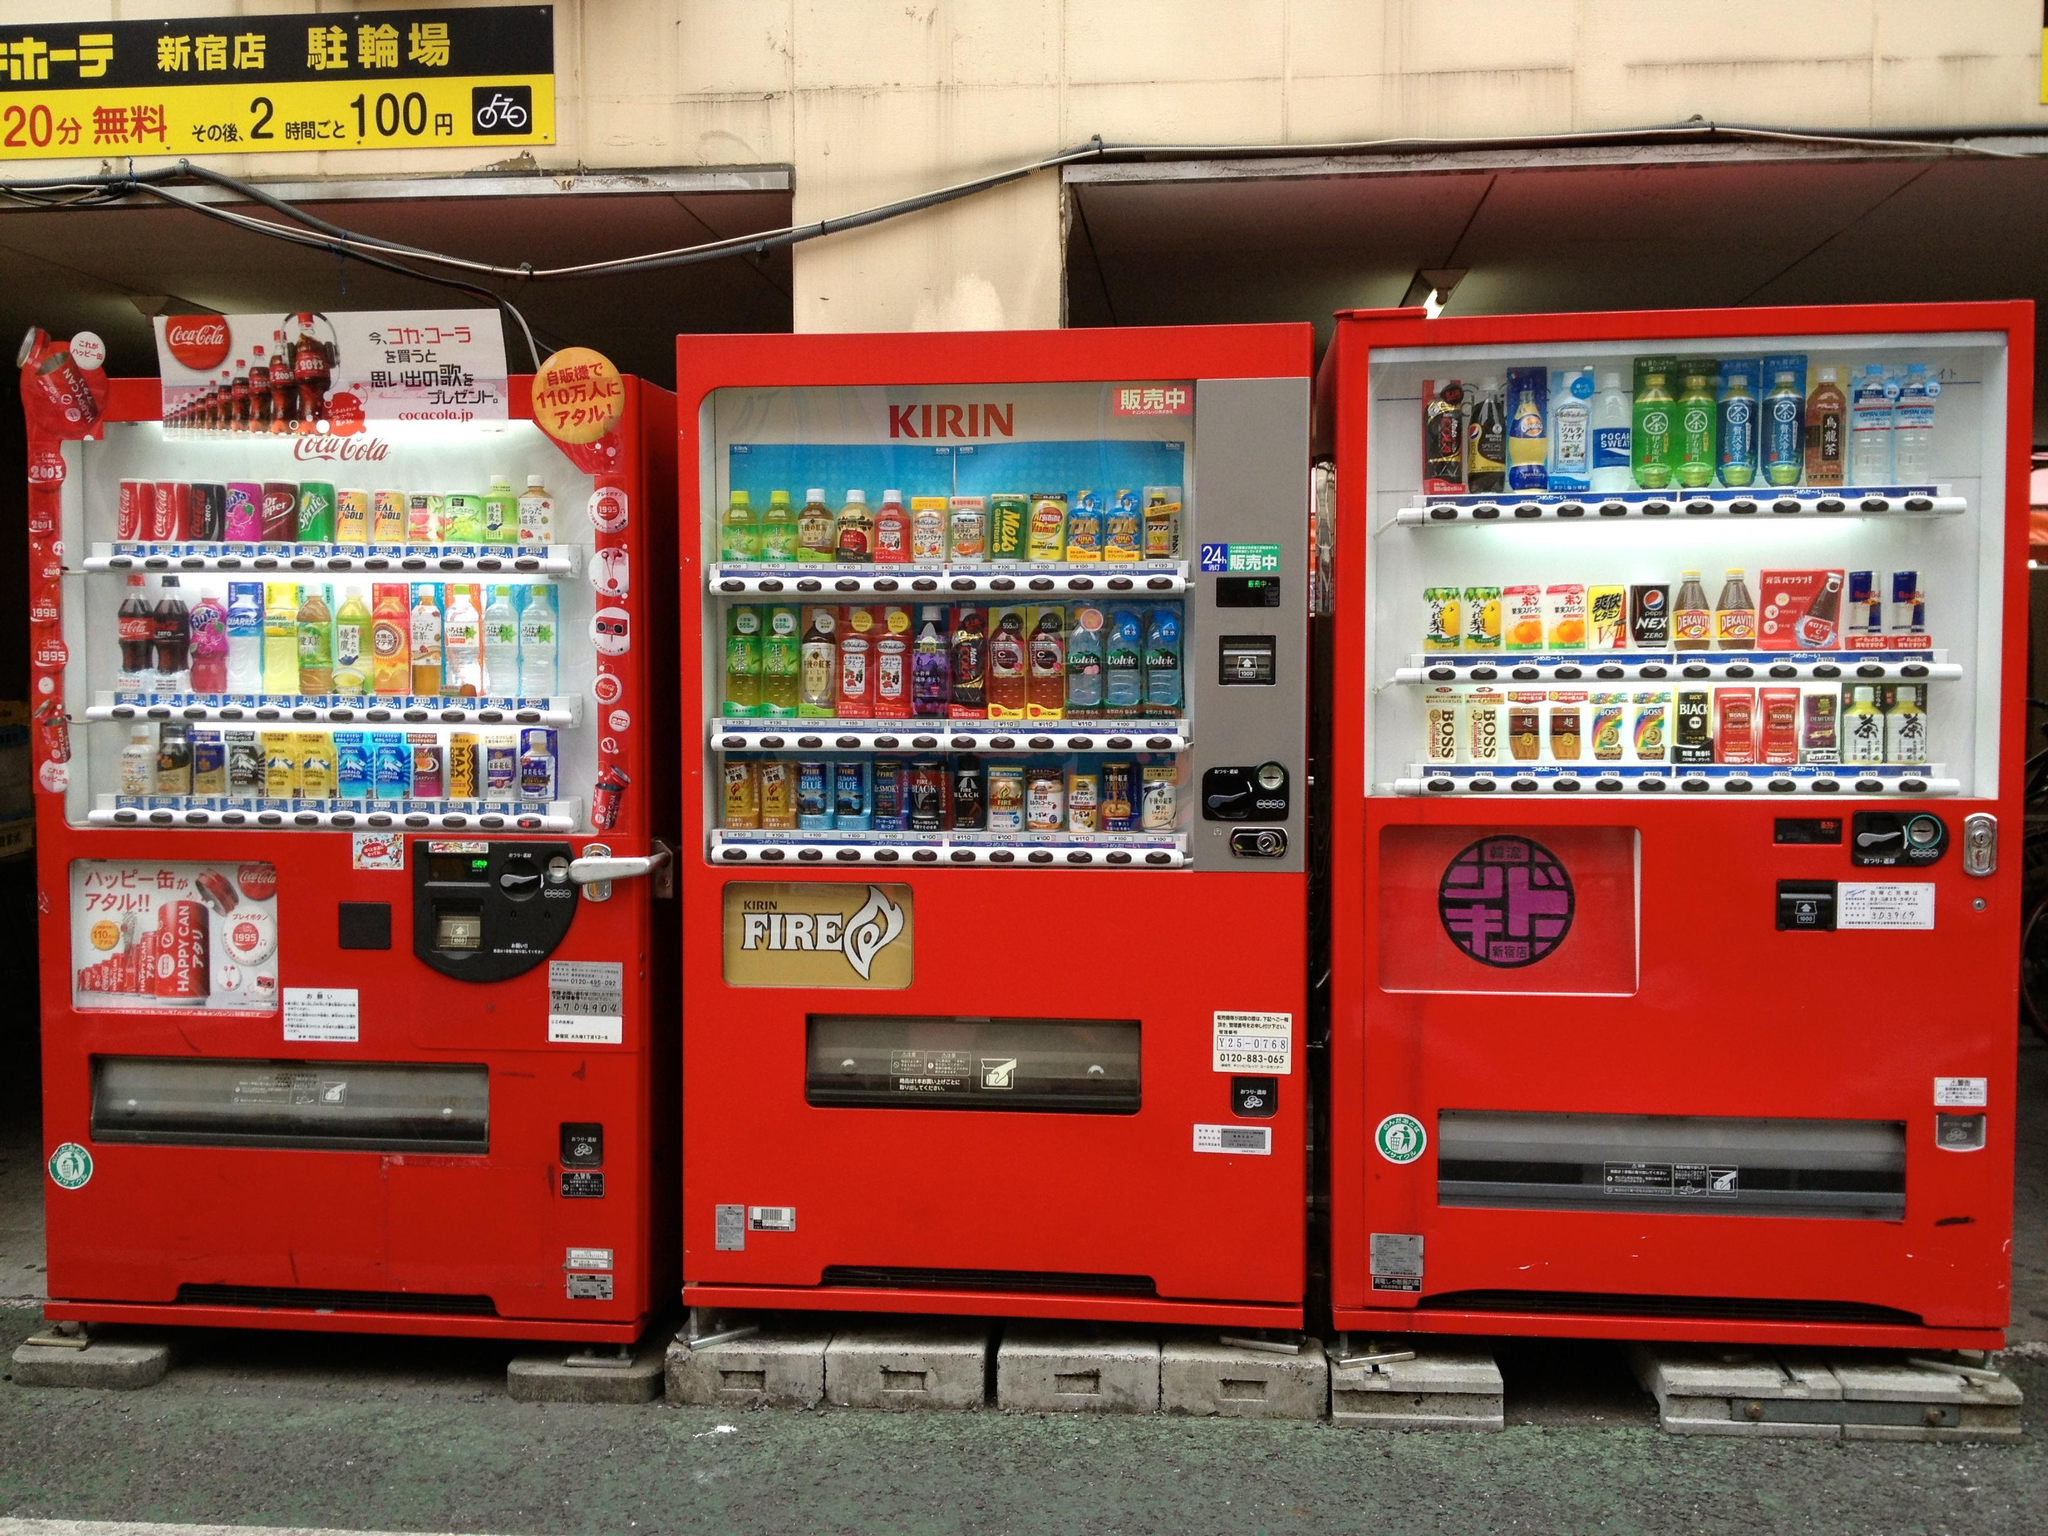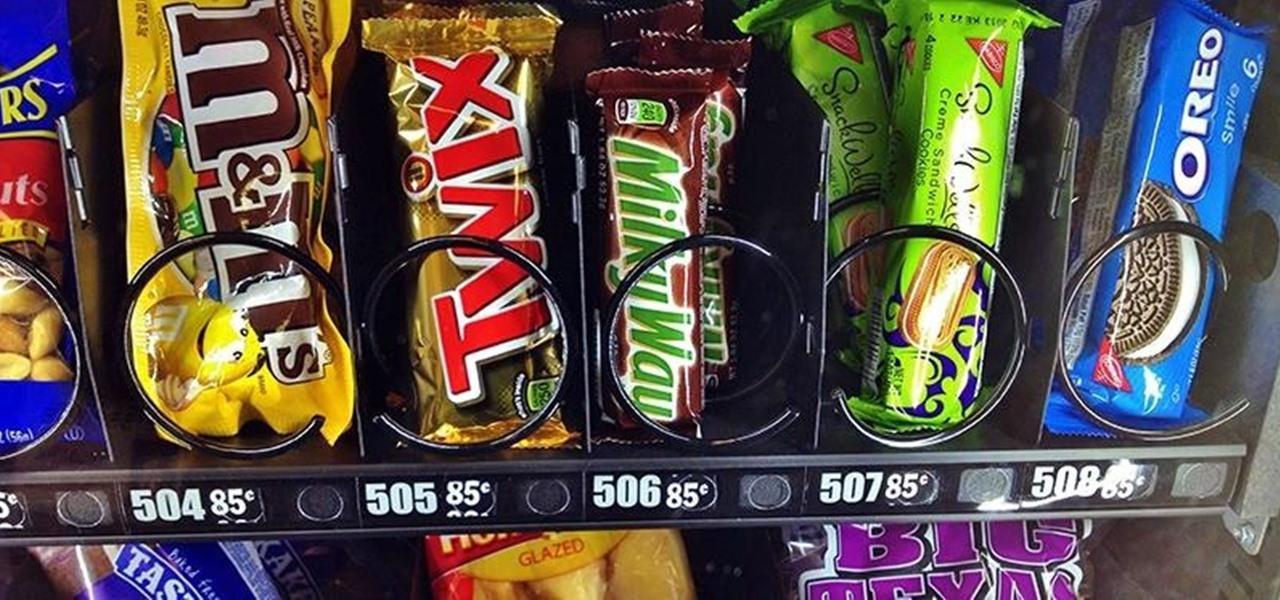The first image is the image on the left, the second image is the image on the right. Given the left and right images, does the statement "Left image shows a vending machine that does not dispense beverages." hold true? Answer yes or no. No. The first image is the image on the left, the second image is the image on the right. For the images displayed, is the sentence "there are red vending machines" factually correct? Answer yes or no. Yes. 